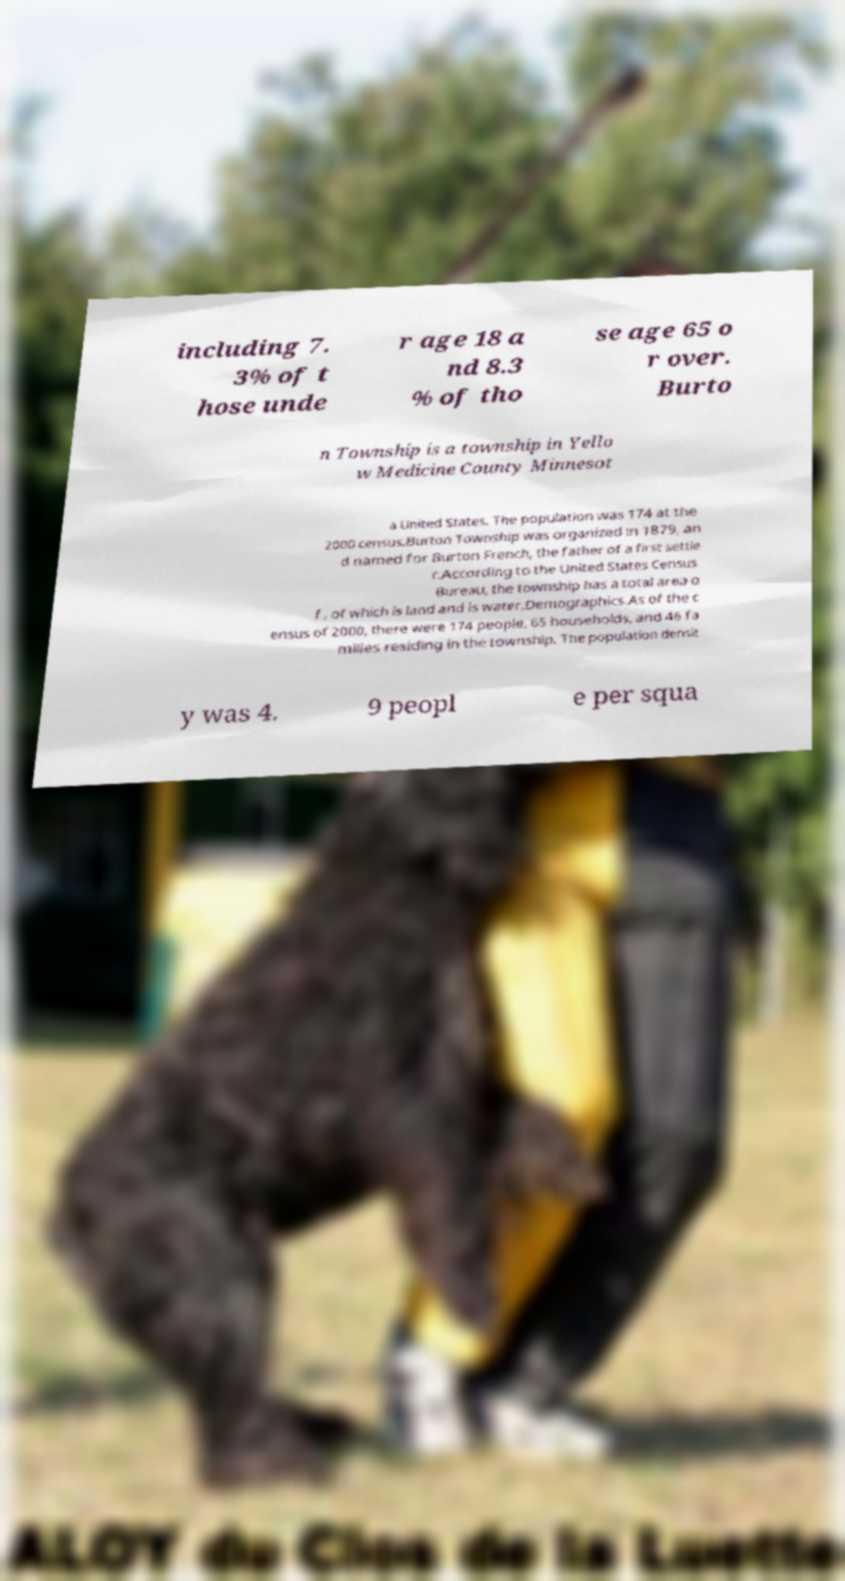For documentation purposes, I need the text within this image transcribed. Could you provide that? including 7. 3% of t hose unde r age 18 a nd 8.3 % of tho se age 65 o r over. Burto n Township is a township in Yello w Medicine County Minnesot a United States. The population was 174 at the 2000 census.Burton Township was organized in 1879, an d named for Burton French, the father of a first settle r.According to the United States Census Bureau, the township has a total area o f , of which is land and is water.Demographics.As of the c ensus of 2000, there were 174 people, 65 households, and 46 fa milies residing in the township. The population densit y was 4. 9 peopl e per squa 